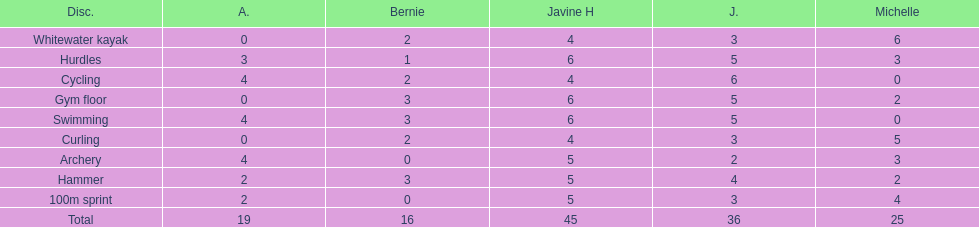Who is the faster runner? Javine H. 